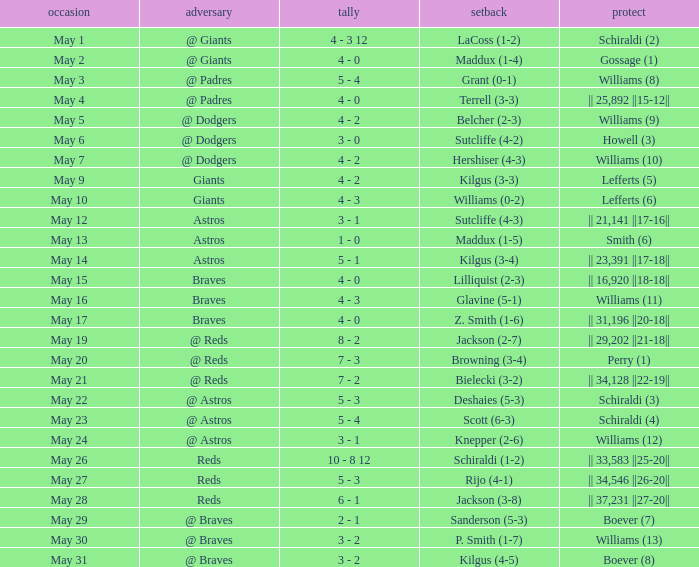Name the loss for may 1 LaCoss (1-2). 